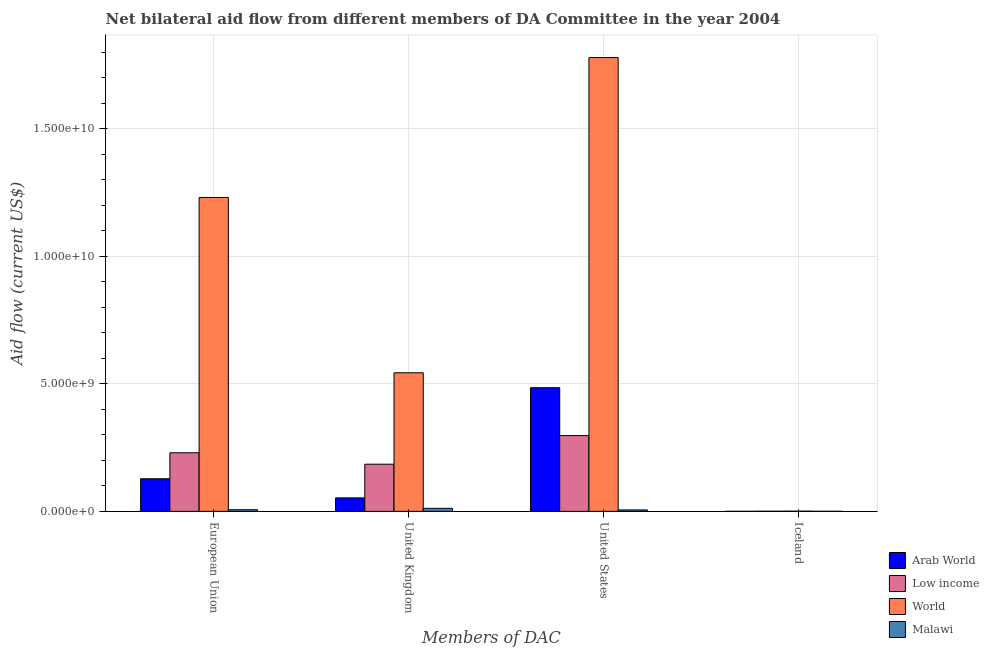How many different coloured bars are there?
Ensure brevity in your answer.  4. How many groups of bars are there?
Your answer should be very brief. 4. Are the number of bars on each tick of the X-axis equal?
Offer a terse response. Yes. How many bars are there on the 2nd tick from the left?
Your answer should be very brief. 4. What is the amount of aid given by iceland in Low income?
Your response must be concise. 4.74e+06. Across all countries, what is the maximum amount of aid given by us?
Make the answer very short. 1.78e+1. Across all countries, what is the minimum amount of aid given by eu?
Provide a succinct answer. 6.44e+07. In which country was the amount of aid given by us minimum?
Offer a terse response. Malawi. What is the total amount of aid given by us in the graph?
Offer a very short reply. 2.57e+1. What is the difference between the amount of aid given by uk in Low income and that in Malawi?
Give a very brief answer. 1.73e+09. What is the difference between the amount of aid given by iceland in Malawi and the amount of aid given by uk in Low income?
Make the answer very short. -1.85e+09. What is the average amount of aid given by uk per country?
Your answer should be very brief. 1.98e+09. What is the difference between the amount of aid given by us and amount of aid given by uk in Malawi?
Provide a short and direct response. -6.28e+07. What is the ratio of the amount of aid given by us in World to that in Arab World?
Your answer should be very brief. 3.67. Is the amount of aid given by iceland in Arab World less than that in Malawi?
Make the answer very short. Yes. Is the difference between the amount of aid given by iceland in Arab World and Malawi greater than the difference between the amount of aid given by eu in Arab World and Malawi?
Your answer should be very brief. No. What is the difference between the highest and the second highest amount of aid given by eu?
Your answer should be very brief. 1.00e+1. What is the difference between the highest and the lowest amount of aid given by us?
Make the answer very short. 1.77e+1. In how many countries, is the amount of aid given by uk greater than the average amount of aid given by uk taken over all countries?
Your answer should be compact. 1. Is it the case that in every country, the sum of the amount of aid given by us and amount of aid given by uk is greater than the sum of amount of aid given by iceland and amount of aid given by eu?
Provide a succinct answer. No. What does the 4th bar from the left in United States represents?
Give a very brief answer. Malawi. How many bars are there?
Provide a succinct answer. 16. Are all the bars in the graph horizontal?
Provide a succinct answer. No. How many countries are there in the graph?
Offer a terse response. 4. What is the difference between two consecutive major ticks on the Y-axis?
Your answer should be very brief. 5.00e+09. Does the graph contain any zero values?
Ensure brevity in your answer.  No. What is the title of the graph?
Ensure brevity in your answer.  Net bilateral aid flow from different members of DA Committee in the year 2004. Does "European Union" appear as one of the legend labels in the graph?
Offer a terse response. No. What is the label or title of the X-axis?
Offer a very short reply. Members of DAC. What is the Aid flow (current US$) of Arab World in European Union?
Your response must be concise. 1.28e+09. What is the Aid flow (current US$) of Low income in European Union?
Provide a succinct answer. 2.30e+09. What is the Aid flow (current US$) in World in European Union?
Give a very brief answer. 1.23e+1. What is the Aid flow (current US$) of Malawi in European Union?
Make the answer very short. 6.44e+07. What is the Aid flow (current US$) of Arab World in United Kingdom?
Provide a short and direct response. 5.28e+08. What is the Aid flow (current US$) of Low income in United Kingdom?
Offer a very short reply. 1.85e+09. What is the Aid flow (current US$) of World in United Kingdom?
Offer a terse response. 5.43e+09. What is the Aid flow (current US$) of Malawi in United Kingdom?
Give a very brief answer. 1.20e+08. What is the Aid flow (current US$) in Arab World in United States?
Offer a terse response. 4.85e+09. What is the Aid flow (current US$) of Low income in United States?
Offer a terse response. 2.97e+09. What is the Aid flow (current US$) of World in United States?
Your answer should be very brief. 1.78e+1. What is the Aid flow (current US$) of Malawi in United States?
Give a very brief answer. 5.68e+07. What is the Aid flow (current US$) of Arab World in Iceland?
Give a very brief answer. 1.54e+06. What is the Aid flow (current US$) of Low income in Iceland?
Make the answer very short. 4.74e+06. What is the Aid flow (current US$) of World in Iceland?
Give a very brief answer. 7.60e+06. What is the Aid flow (current US$) in Malawi in Iceland?
Offer a terse response. 2.28e+06. Across all Members of DAC, what is the maximum Aid flow (current US$) in Arab World?
Provide a short and direct response. 4.85e+09. Across all Members of DAC, what is the maximum Aid flow (current US$) of Low income?
Provide a succinct answer. 2.97e+09. Across all Members of DAC, what is the maximum Aid flow (current US$) in World?
Provide a short and direct response. 1.78e+1. Across all Members of DAC, what is the maximum Aid flow (current US$) of Malawi?
Keep it short and to the point. 1.20e+08. Across all Members of DAC, what is the minimum Aid flow (current US$) in Arab World?
Offer a terse response. 1.54e+06. Across all Members of DAC, what is the minimum Aid flow (current US$) of Low income?
Provide a short and direct response. 4.74e+06. Across all Members of DAC, what is the minimum Aid flow (current US$) in World?
Give a very brief answer. 7.60e+06. Across all Members of DAC, what is the minimum Aid flow (current US$) in Malawi?
Provide a short and direct response. 2.28e+06. What is the total Aid flow (current US$) of Arab World in the graph?
Give a very brief answer. 6.65e+09. What is the total Aid flow (current US$) in Low income in the graph?
Provide a short and direct response. 7.12e+09. What is the total Aid flow (current US$) in World in the graph?
Ensure brevity in your answer.  3.55e+1. What is the total Aid flow (current US$) in Malawi in the graph?
Provide a short and direct response. 2.43e+08. What is the difference between the Aid flow (current US$) in Arab World in European Union and that in United Kingdom?
Keep it short and to the point. 7.50e+08. What is the difference between the Aid flow (current US$) of Low income in European Union and that in United Kingdom?
Offer a terse response. 4.47e+08. What is the difference between the Aid flow (current US$) in World in European Union and that in United Kingdom?
Ensure brevity in your answer.  6.87e+09. What is the difference between the Aid flow (current US$) in Malawi in European Union and that in United Kingdom?
Ensure brevity in your answer.  -5.51e+07. What is the difference between the Aid flow (current US$) in Arab World in European Union and that in United States?
Provide a short and direct response. -3.57e+09. What is the difference between the Aid flow (current US$) of Low income in European Union and that in United States?
Your response must be concise. -6.75e+08. What is the difference between the Aid flow (current US$) of World in European Union and that in United States?
Your response must be concise. -5.48e+09. What is the difference between the Aid flow (current US$) of Malawi in European Union and that in United States?
Offer a very short reply. 7.69e+06. What is the difference between the Aid flow (current US$) of Arab World in European Union and that in Iceland?
Keep it short and to the point. 1.28e+09. What is the difference between the Aid flow (current US$) in Low income in European Union and that in Iceland?
Offer a terse response. 2.29e+09. What is the difference between the Aid flow (current US$) of World in European Union and that in Iceland?
Ensure brevity in your answer.  1.23e+1. What is the difference between the Aid flow (current US$) of Malawi in European Union and that in Iceland?
Your answer should be compact. 6.22e+07. What is the difference between the Aid flow (current US$) in Arab World in United Kingdom and that in United States?
Your answer should be very brief. -4.32e+09. What is the difference between the Aid flow (current US$) of Low income in United Kingdom and that in United States?
Your response must be concise. -1.12e+09. What is the difference between the Aid flow (current US$) in World in United Kingdom and that in United States?
Keep it short and to the point. -1.24e+1. What is the difference between the Aid flow (current US$) in Malawi in United Kingdom and that in United States?
Offer a very short reply. 6.28e+07. What is the difference between the Aid flow (current US$) of Arab World in United Kingdom and that in Iceland?
Give a very brief answer. 5.26e+08. What is the difference between the Aid flow (current US$) of Low income in United Kingdom and that in Iceland?
Offer a terse response. 1.84e+09. What is the difference between the Aid flow (current US$) in World in United Kingdom and that in Iceland?
Ensure brevity in your answer.  5.42e+09. What is the difference between the Aid flow (current US$) of Malawi in United Kingdom and that in Iceland?
Keep it short and to the point. 1.17e+08. What is the difference between the Aid flow (current US$) of Arab World in United States and that in Iceland?
Your response must be concise. 4.84e+09. What is the difference between the Aid flow (current US$) of Low income in United States and that in Iceland?
Keep it short and to the point. 2.97e+09. What is the difference between the Aid flow (current US$) of World in United States and that in Iceland?
Provide a succinct answer. 1.78e+1. What is the difference between the Aid flow (current US$) in Malawi in United States and that in Iceland?
Provide a succinct answer. 5.45e+07. What is the difference between the Aid flow (current US$) in Arab World in European Union and the Aid flow (current US$) in Low income in United Kingdom?
Keep it short and to the point. -5.70e+08. What is the difference between the Aid flow (current US$) of Arab World in European Union and the Aid flow (current US$) of World in United Kingdom?
Offer a very short reply. -4.15e+09. What is the difference between the Aid flow (current US$) in Arab World in European Union and the Aid flow (current US$) in Malawi in United Kingdom?
Provide a succinct answer. 1.16e+09. What is the difference between the Aid flow (current US$) of Low income in European Union and the Aid flow (current US$) of World in United Kingdom?
Your answer should be compact. -3.14e+09. What is the difference between the Aid flow (current US$) of Low income in European Union and the Aid flow (current US$) of Malawi in United Kingdom?
Offer a terse response. 2.18e+09. What is the difference between the Aid flow (current US$) in World in European Union and the Aid flow (current US$) in Malawi in United Kingdom?
Give a very brief answer. 1.22e+1. What is the difference between the Aid flow (current US$) of Arab World in European Union and the Aid flow (current US$) of Low income in United States?
Your response must be concise. -1.69e+09. What is the difference between the Aid flow (current US$) of Arab World in European Union and the Aid flow (current US$) of World in United States?
Your answer should be very brief. -1.65e+1. What is the difference between the Aid flow (current US$) of Arab World in European Union and the Aid flow (current US$) of Malawi in United States?
Give a very brief answer. 1.22e+09. What is the difference between the Aid flow (current US$) of Low income in European Union and the Aid flow (current US$) of World in United States?
Offer a very short reply. -1.55e+1. What is the difference between the Aid flow (current US$) of Low income in European Union and the Aid flow (current US$) of Malawi in United States?
Provide a succinct answer. 2.24e+09. What is the difference between the Aid flow (current US$) in World in European Union and the Aid flow (current US$) in Malawi in United States?
Provide a succinct answer. 1.22e+1. What is the difference between the Aid flow (current US$) of Arab World in European Union and the Aid flow (current US$) of Low income in Iceland?
Your answer should be very brief. 1.27e+09. What is the difference between the Aid flow (current US$) in Arab World in European Union and the Aid flow (current US$) in World in Iceland?
Offer a terse response. 1.27e+09. What is the difference between the Aid flow (current US$) of Arab World in European Union and the Aid flow (current US$) of Malawi in Iceland?
Provide a succinct answer. 1.28e+09. What is the difference between the Aid flow (current US$) in Low income in European Union and the Aid flow (current US$) in World in Iceland?
Provide a short and direct response. 2.29e+09. What is the difference between the Aid flow (current US$) in Low income in European Union and the Aid flow (current US$) in Malawi in Iceland?
Ensure brevity in your answer.  2.29e+09. What is the difference between the Aid flow (current US$) in World in European Union and the Aid flow (current US$) in Malawi in Iceland?
Provide a succinct answer. 1.23e+1. What is the difference between the Aid flow (current US$) in Arab World in United Kingdom and the Aid flow (current US$) in Low income in United States?
Offer a terse response. -2.44e+09. What is the difference between the Aid flow (current US$) in Arab World in United Kingdom and the Aid flow (current US$) in World in United States?
Your answer should be very brief. -1.73e+1. What is the difference between the Aid flow (current US$) in Arab World in United Kingdom and the Aid flow (current US$) in Malawi in United States?
Provide a succinct answer. 4.71e+08. What is the difference between the Aid flow (current US$) in Low income in United Kingdom and the Aid flow (current US$) in World in United States?
Ensure brevity in your answer.  -1.59e+1. What is the difference between the Aid flow (current US$) of Low income in United Kingdom and the Aid flow (current US$) of Malawi in United States?
Your response must be concise. 1.79e+09. What is the difference between the Aid flow (current US$) in World in United Kingdom and the Aid flow (current US$) in Malawi in United States?
Your answer should be very brief. 5.37e+09. What is the difference between the Aid flow (current US$) of Arab World in United Kingdom and the Aid flow (current US$) of Low income in Iceland?
Offer a terse response. 5.23e+08. What is the difference between the Aid flow (current US$) in Arab World in United Kingdom and the Aid flow (current US$) in World in Iceland?
Ensure brevity in your answer.  5.20e+08. What is the difference between the Aid flow (current US$) of Arab World in United Kingdom and the Aid flow (current US$) of Malawi in Iceland?
Your answer should be very brief. 5.26e+08. What is the difference between the Aid flow (current US$) in Low income in United Kingdom and the Aid flow (current US$) in World in Iceland?
Provide a short and direct response. 1.84e+09. What is the difference between the Aid flow (current US$) in Low income in United Kingdom and the Aid flow (current US$) in Malawi in Iceland?
Keep it short and to the point. 1.85e+09. What is the difference between the Aid flow (current US$) of World in United Kingdom and the Aid flow (current US$) of Malawi in Iceland?
Your answer should be compact. 5.43e+09. What is the difference between the Aid flow (current US$) of Arab World in United States and the Aid flow (current US$) of Low income in Iceland?
Your answer should be compact. 4.84e+09. What is the difference between the Aid flow (current US$) in Arab World in United States and the Aid flow (current US$) in World in Iceland?
Keep it short and to the point. 4.84e+09. What is the difference between the Aid flow (current US$) in Arab World in United States and the Aid flow (current US$) in Malawi in Iceland?
Your response must be concise. 4.84e+09. What is the difference between the Aid flow (current US$) of Low income in United States and the Aid flow (current US$) of World in Iceland?
Your response must be concise. 2.96e+09. What is the difference between the Aid flow (current US$) of Low income in United States and the Aid flow (current US$) of Malawi in Iceland?
Provide a succinct answer. 2.97e+09. What is the difference between the Aid flow (current US$) in World in United States and the Aid flow (current US$) in Malawi in Iceland?
Provide a short and direct response. 1.78e+1. What is the average Aid flow (current US$) of Arab World per Members of DAC?
Keep it short and to the point. 1.66e+09. What is the average Aid flow (current US$) of Low income per Members of DAC?
Provide a succinct answer. 1.78e+09. What is the average Aid flow (current US$) of World per Members of DAC?
Ensure brevity in your answer.  8.88e+09. What is the average Aid flow (current US$) in Malawi per Members of DAC?
Your answer should be very brief. 6.07e+07. What is the difference between the Aid flow (current US$) of Arab World and Aid flow (current US$) of Low income in European Union?
Provide a short and direct response. -1.02e+09. What is the difference between the Aid flow (current US$) of Arab World and Aid flow (current US$) of World in European Union?
Give a very brief answer. -1.10e+1. What is the difference between the Aid flow (current US$) of Arab World and Aid flow (current US$) of Malawi in European Union?
Your answer should be compact. 1.21e+09. What is the difference between the Aid flow (current US$) of Low income and Aid flow (current US$) of World in European Union?
Give a very brief answer. -1.00e+1. What is the difference between the Aid flow (current US$) of Low income and Aid flow (current US$) of Malawi in European Union?
Make the answer very short. 2.23e+09. What is the difference between the Aid flow (current US$) of World and Aid flow (current US$) of Malawi in European Union?
Offer a terse response. 1.22e+1. What is the difference between the Aid flow (current US$) in Arab World and Aid flow (current US$) in Low income in United Kingdom?
Your answer should be compact. -1.32e+09. What is the difference between the Aid flow (current US$) in Arab World and Aid flow (current US$) in World in United Kingdom?
Your response must be concise. -4.90e+09. What is the difference between the Aid flow (current US$) of Arab World and Aid flow (current US$) of Malawi in United Kingdom?
Your answer should be very brief. 4.09e+08. What is the difference between the Aid flow (current US$) in Low income and Aid flow (current US$) in World in United Kingdom?
Your answer should be very brief. -3.58e+09. What is the difference between the Aid flow (current US$) of Low income and Aid flow (current US$) of Malawi in United Kingdom?
Ensure brevity in your answer.  1.73e+09. What is the difference between the Aid flow (current US$) of World and Aid flow (current US$) of Malawi in United Kingdom?
Offer a very short reply. 5.31e+09. What is the difference between the Aid flow (current US$) in Arab World and Aid flow (current US$) in Low income in United States?
Your answer should be very brief. 1.88e+09. What is the difference between the Aid flow (current US$) of Arab World and Aid flow (current US$) of World in United States?
Keep it short and to the point. -1.29e+1. What is the difference between the Aid flow (current US$) of Arab World and Aid flow (current US$) of Malawi in United States?
Make the answer very short. 4.79e+09. What is the difference between the Aid flow (current US$) in Low income and Aid flow (current US$) in World in United States?
Keep it short and to the point. -1.48e+1. What is the difference between the Aid flow (current US$) in Low income and Aid flow (current US$) in Malawi in United States?
Make the answer very short. 2.91e+09. What is the difference between the Aid flow (current US$) of World and Aid flow (current US$) of Malawi in United States?
Ensure brevity in your answer.  1.77e+1. What is the difference between the Aid flow (current US$) in Arab World and Aid flow (current US$) in Low income in Iceland?
Offer a terse response. -3.20e+06. What is the difference between the Aid flow (current US$) in Arab World and Aid flow (current US$) in World in Iceland?
Ensure brevity in your answer.  -6.06e+06. What is the difference between the Aid flow (current US$) of Arab World and Aid flow (current US$) of Malawi in Iceland?
Your answer should be compact. -7.40e+05. What is the difference between the Aid flow (current US$) in Low income and Aid flow (current US$) in World in Iceland?
Offer a terse response. -2.86e+06. What is the difference between the Aid flow (current US$) of Low income and Aid flow (current US$) of Malawi in Iceland?
Provide a short and direct response. 2.46e+06. What is the difference between the Aid flow (current US$) of World and Aid flow (current US$) of Malawi in Iceland?
Your response must be concise. 5.32e+06. What is the ratio of the Aid flow (current US$) of Arab World in European Union to that in United Kingdom?
Your answer should be compact. 2.42. What is the ratio of the Aid flow (current US$) in Low income in European Union to that in United Kingdom?
Your response must be concise. 1.24. What is the ratio of the Aid flow (current US$) in World in European Union to that in United Kingdom?
Your answer should be very brief. 2.27. What is the ratio of the Aid flow (current US$) in Malawi in European Union to that in United Kingdom?
Ensure brevity in your answer.  0.54. What is the ratio of the Aid flow (current US$) in Arab World in European Union to that in United States?
Ensure brevity in your answer.  0.26. What is the ratio of the Aid flow (current US$) of Low income in European Union to that in United States?
Keep it short and to the point. 0.77. What is the ratio of the Aid flow (current US$) in World in European Union to that in United States?
Make the answer very short. 0.69. What is the ratio of the Aid flow (current US$) in Malawi in European Union to that in United States?
Your response must be concise. 1.14. What is the ratio of the Aid flow (current US$) of Arab World in European Union to that in Iceland?
Keep it short and to the point. 829.75. What is the ratio of the Aid flow (current US$) in Low income in European Union to that in Iceland?
Your response must be concise. 484.25. What is the ratio of the Aid flow (current US$) of World in European Union to that in Iceland?
Give a very brief answer. 1618.65. What is the ratio of the Aid flow (current US$) of Malawi in European Union to that in Iceland?
Ensure brevity in your answer.  28.26. What is the ratio of the Aid flow (current US$) of Arab World in United Kingdom to that in United States?
Offer a terse response. 0.11. What is the ratio of the Aid flow (current US$) of Low income in United Kingdom to that in United States?
Your response must be concise. 0.62. What is the ratio of the Aid flow (current US$) in World in United Kingdom to that in United States?
Provide a succinct answer. 0.31. What is the ratio of the Aid flow (current US$) in Malawi in United Kingdom to that in United States?
Provide a short and direct response. 2.11. What is the ratio of the Aid flow (current US$) in Arab World in United Kingdom to that in Iceland?
Keep it short and to the point. 342.87. What is the ratio of the Aid flow (current US$) of Low income in United Kingdom to that in Iceland?
Provide a short and direct response. 389.91. What is the ratio of the Aid flow (current US$) of World in United Kingdom to that in Iceland?
Provide a succinct answer. 714.59. What is the ratio of the Aid flow (current US$) of Malawi in United Kingdom to that in Iceland?
Provide a short and direct response. 52.41. What is the ratio of the Aid flow (current US$) in Arab World in United States to that in Iceland?
Offer a terse response. 3146.99. What is the ratio of the Aid flow (current US$) of Low income in United States to that in Iceland?
Your response must be concise. 626.69. What is the ratio of the Aid flow (current US$) of World in United States to that in Iceland?
Offer a very short reply. 2340.13. What is the ratio of the Aid flow (current US$) in Malawi in United States to that in Iceland?
Offer a very short reply. 24.89. What is the difference between the highest and the second highest Aid flow (current US$) in Arab World?
Provide a succinct answer. 3.57e+09. What is the difference between the highest and the second highest Aid flow (current US$) in Low income?
Offer a very short reply. 6.75e+08. What is the difference between the highest and the second highest Aid flow (current US$) in World?
Your answer should be compact. 5.48e+09. What is the difference between the highest and the second highest Aid flow (current US$) in Malawi?
Your answer should be very brief. 5.51e+07. What is the difference between the highest and the lowest Aid flow (current US$) in Arab World?
Keep it short and to the point. 4.84e+09. What is the difference between the highest and the lowest Aid flow (current US$) in Low income?
Make the answer very short. 2.97e+09. What is the difference between the highest and the lowest Aid flow (current US$) in World?
Provide a succinct answer. 1.78e+1. What is the difference between the highest and the lowest Aid flow (current US$) of Malawi?
Keep it short and to the point. 1.17e+08. 